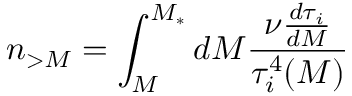Convert formula to latex. <formula><loc_0><loc_0><loc_500><loc_500>n _ { > M } = \int _ { M } ^ { M _ { * } } d M { \frac { \nu { \frac { d \tau _ { i } } { d M } } } { \tau _ { i } ^ { 4 } ( M ) } }</formula> 